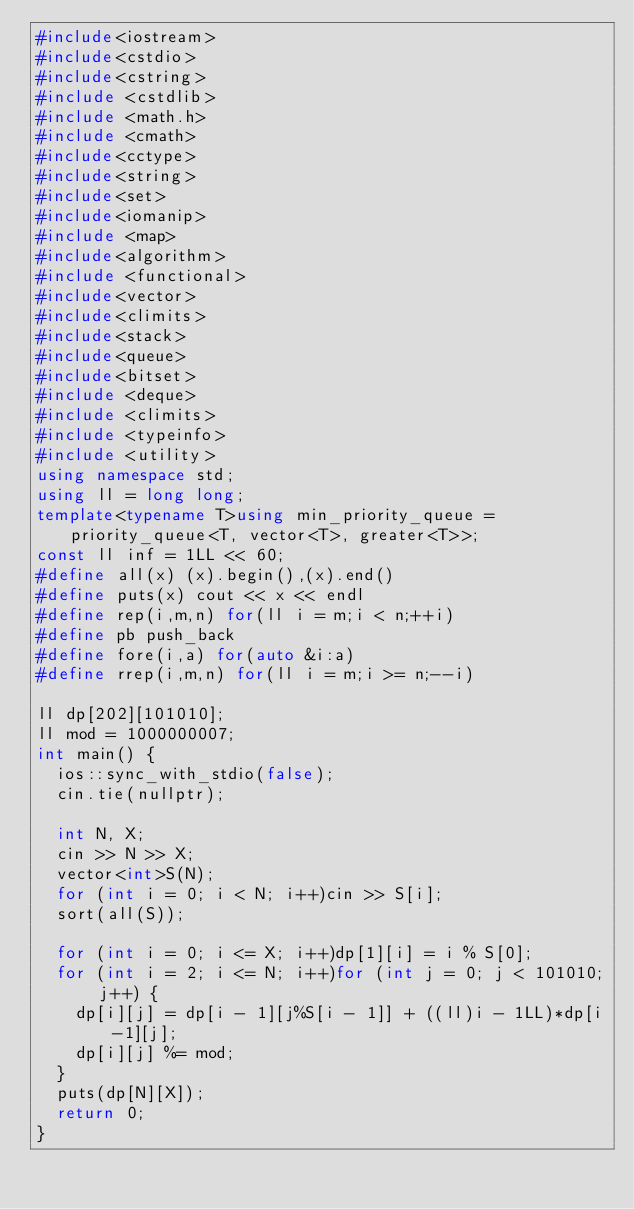Convert code to text. <code><loc_0><loc_0><loc_500><loc_500><_C++_>#include<iostream>
#include<cstdio>
#include<cstring>
#include <cstdlib>  
#include <math.h>
#include <cmath>
#include<cctype>
#include<string>
#include<set>
#include<iomanip>
#include <map>
#include<algorithm>
#include <functional>
#include<vector>
#include<climits>
#include<stack>
#include<queue>
#include<bitset>
#include <deque>
#include <climits>
#include <typeinfo>
#include <utility> 
using namespace std;
using ll = long long;
template<typename T>using min_priority_queue = priority_queue<T, vector<T>, greater<T>>;
const ll inf = 1LL << 60;
#define all(x) (x).begin(),(x).end()
#define puts(x) cout << x << endl
#define rep(i,m,n) for(ll i = m;i < n;++i)
#define pb push_back
#define fore(i,a) for(auto &i:a)
#define rrep(i,m,n) for(ll i = m;i >= n;--i)

ll dp[202][101010];
ll mod = 1000000007;
int main() {
	ios::sync_with_stdio(false);
	cin.tie(nullptr);

	int N, X;
	cin >> N >> X;
	vector<int>S(N);
	for (int i = 0; i < N; i++)cin >> S[i];
	sort(all(S));

	for (int i = 0; i <= X; i++)dp[1][i] = i % S[0];
	for (int i = 2; i <= N; i++)for (int j = 0; j < 101010; j++) {
		dp[i][j] = dp[i - 1][j%S[i - 1]] + ((ll)i - 1LL)*dp[i-1][j];
		dp[i][j] %= mod;
	}
	puts(dp[N][X]);
	return 0;
}

</code> 